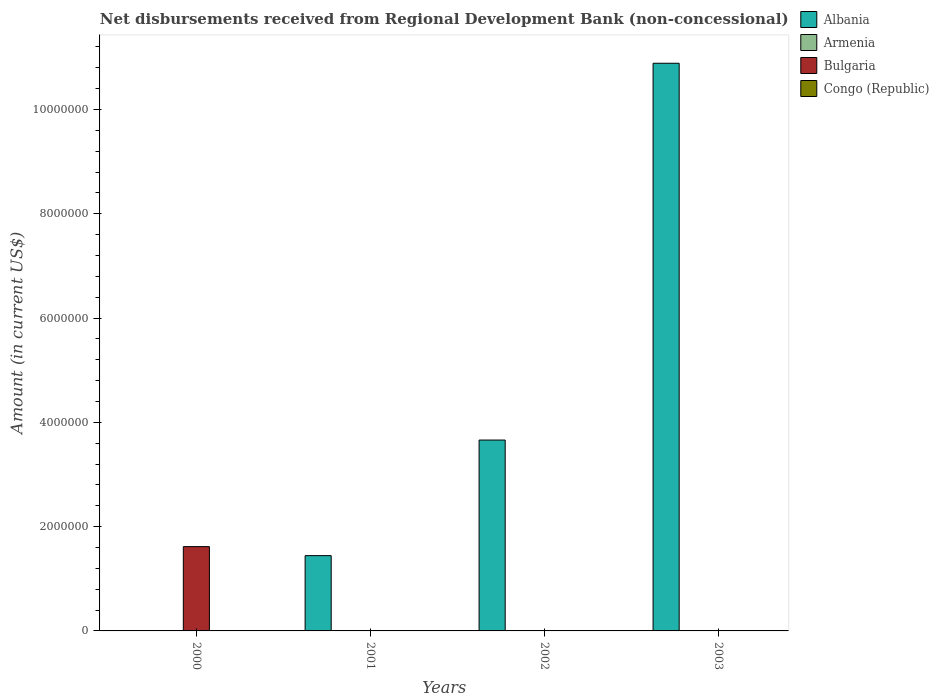Are the number of bars per tick equal to the number of legend labels?
Make the answer very short. No. How many bars are there on the 1st tick from the right?
Your answer should be compact. 1. What is the label of the 2nd group of bars from the left?
Your answer should be very brief. 2001. What is the amount of disbursements received from Regional Development Bank in Armenia in 2001?
Your answer should be very brief. 0. Across all years, what is the maximum amount of disbursements received from Regional Development Bank in Bulgaria?
Make the answer very short. 1.62e+06. Across all years, what is the minimum amount of disbursements received from Regional Development Bank in Albania?
Keep it short and to the point. 0. What is the total amount of disbursements received from Regional Development Bank in Bulgaria in the graph?
Ensure brevity in your answer.  1.62e+06. What is the difference between the amount of disbursements received from Regional Development Bank in Albania in 2002 and that in 2003?
Your answer should be very brief. -7.23e+06. What is the difference between the amount of disbursements received from Regional Development Bank in Armenia in 2001 and the amount of disbursements received from Regional Development Bank in Albania in 2002?
Your response must be concise. -3.66e+06. What is the average amount of disbursements received from Regional Development Bank in Armenia per year?
Provide a short and direct response. 0. In how many years, is the amount of disbursements received from Regional Development Bank in Bulgaria greater than 7600000 US$?
Your answer should be very brief. 0. What is the ratio of the amount of disbursements received from Regional Development Bank in Albania in 2001 to that in 2003?
Make the answer very short. 0.13. Is the amount of disbursements received from Regional Development Bank in Albania in 2001 less than that in 2002?
Provide a short and direct response. Yes. What is the difference between the highest and the second highest amount of disbursements received from Regional Development Bank in Albania?
Your answer should be very brief. 7.23e+06. What is the difference between the highest and the lowest amount of disbursements received from Regional Development Bank in Bulgaria?
Offer a very short reply. 1.62e+06. Is it the case that in every year, the sum of the amount of disbursements received from Regional Development Bank in Armenia and amount of disbursements received from Regional Development Bank in Bulgaria is greater than the sum of amount of disbursements received from Regional Development Bank in Congo (Republic) and amount of disbursements received from Regional Development Bank in Albania?
Ensure brevity in your answer.  No. Are all the bars in the graph horizontal?
Your answer should be very brief. No. What is the difference between two consecutive major ticks on the Y-axis?
Offer a very short reply. 2.00e+06. Does the graph contain grids?
Your response must be concise. No. How are the legend labels stacked?
Keep it short and to the point. Vertical. What is the title of the graph?
Offer a very short reply. Net disbursements received from Regional Development Bank (non-concessional). What is the label or title of the Y-axis?
Provide a short and direct response. Amount (in current US$). What is the Amount (in current US$) in Bulgaria in 2000?
Keep it short and to the point. 1.62e+06. What is the Amount (in current US$) of Congo (Republic) in 2000?
Offer a terse response. 0. What is the Amount (in current US$) in Albania in 2001?
Make the answer very short. 1.44e+06. What is the Amount (in current US$) of Albania in 2002?
Offer a very short reply. 3.66e+06. What is the Amount (in current US$) of Albania in 2003?
Make the answer very short. 1.09e+07. Across all years, what is the maximum Amount (in current US$) in Albania?
Offer a terse response. 1.09e+07. Across all years, what is the maximum Amount (in current US$) in Bulgaria?
Offer a terse response. 1.62e+06. What is the total Amount (in current US$) of Albania in the graph?
Offer a terse response. 1.60e+07. What is the total Amount (in current US$) of Bulgaria in the graph?
Keep it short and to the point. 1.62e+06. What is the difference between the Amount (in current US$) in Albania in 2001 and that in 2002?
Provide a short and direct response. -2.22e+06. What is the difference between the Amount (in current US$) in Albania in 2001 and that in 2003?
Offer a very short reply. -9.44e+06. What is the difference between the Amount (in current US$) in Albania in 2002 and that in 2003?
Offer a very short reply. -7.23e+06. What is the average Amount (in current US$) in Albania per year?
Offer a terse response. 4.00e+06. What is the average Amount (in current US$) of Bulgaria per year?
Your answer should be compact. 4.04e+05. What is the ratio of the Amount (in current US$) of Albania in 2001 to that in 2002?
Provide a short and direct response. 0.39. What is the ratio of the Amount (in current US$) of Albania in 2001 to that in 2003?
Make the answer very short. 0.13. What is the ratio of the Amount (in current US$) in Albania in 2002 to that in 2003?
Provide a succinct answer. 0.34. What is the difference between the highest and the second highest Amount (in current US$) in Albania?
Provide a short and direct response. 7.23e+06. What is the difference between the highest and the lowest Amount (in current US$) in Albania?
Provide a succinct answer. 1.09e+07. What is the difference between the highest and the lowest Amount (in current US$) in Bulgaria?
Offer a terse response. 1.62e+06. 